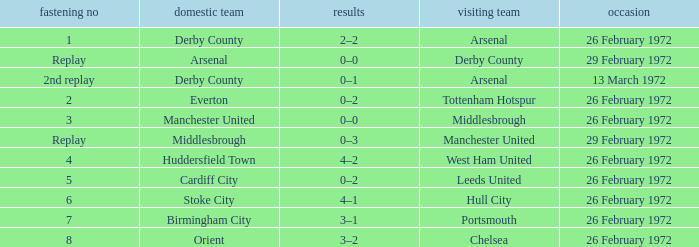I'm looking to parse the entire table for insights. Could you assist me with that? {'header': ['fastening no', 'domestic team', 'results', 'visiting team', 'occasion'], 'rows': [['1', 'Derby County', '2–2', 'Arsenal', '26 February 1972'], ['Replay', 'Arsenal', '0–0', 'Derby County', '29 February 1972'], ['2nd replay', 'Derby County', '0–1', 'Arsenal', '13 March 1972'], ['2', 'Everton', '0–2', 'Tottenham Hotspur', '26 February 1972'], ['3', 'Manchester United', '0–0', 'Middlesbrough', '26 February 1972'], ['Replay', 'Middlesbrough', '0–3', 'Manchester United', '29 February 1972'], ['4', 'Huddersfield Town', '4–2', 'West Ham United', '26 February 1972'], ['5', 'Cardiff City', '0–2', 'Leeds United', '26 February 1972'], ['6', 'Stoke City', '4–1', 'Hull City', '26 February 1972'], ['7', 'Birmingham City', '3–1', 'Portsmouth', '26 February 1972'], ['8', 'Orient', '3–2', 'Chelsea', '26 February 1972']]} Which Tie is from birmingham city? 7.0. 